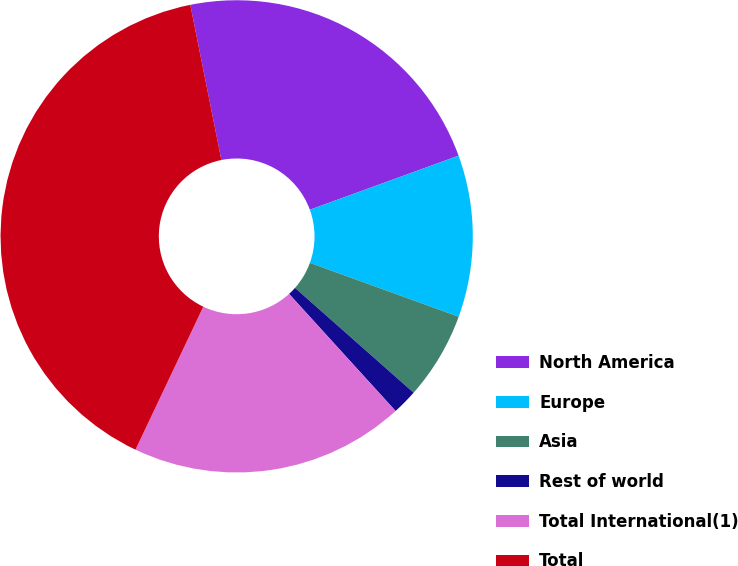<chart> <loc_0><loc_0><loc_500><loc_500><pie_chart><fcel>North America<fcel>Europe<fcel>Asia<fcel>Rest of world<fcel>Total International(1)<fcel>Total<nl><fcel>22.6%<fcel>11.08%<fcel>5.99%<fcel>1.73%<fcel>18.8%<fcel>39.81%<nl></chart> 